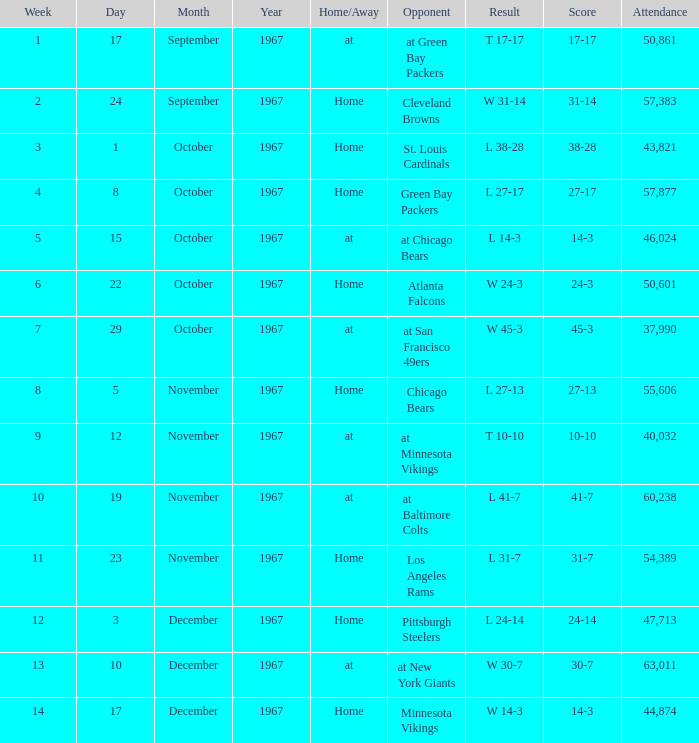How many weeks have a Result of t 10-10? 1.0. 